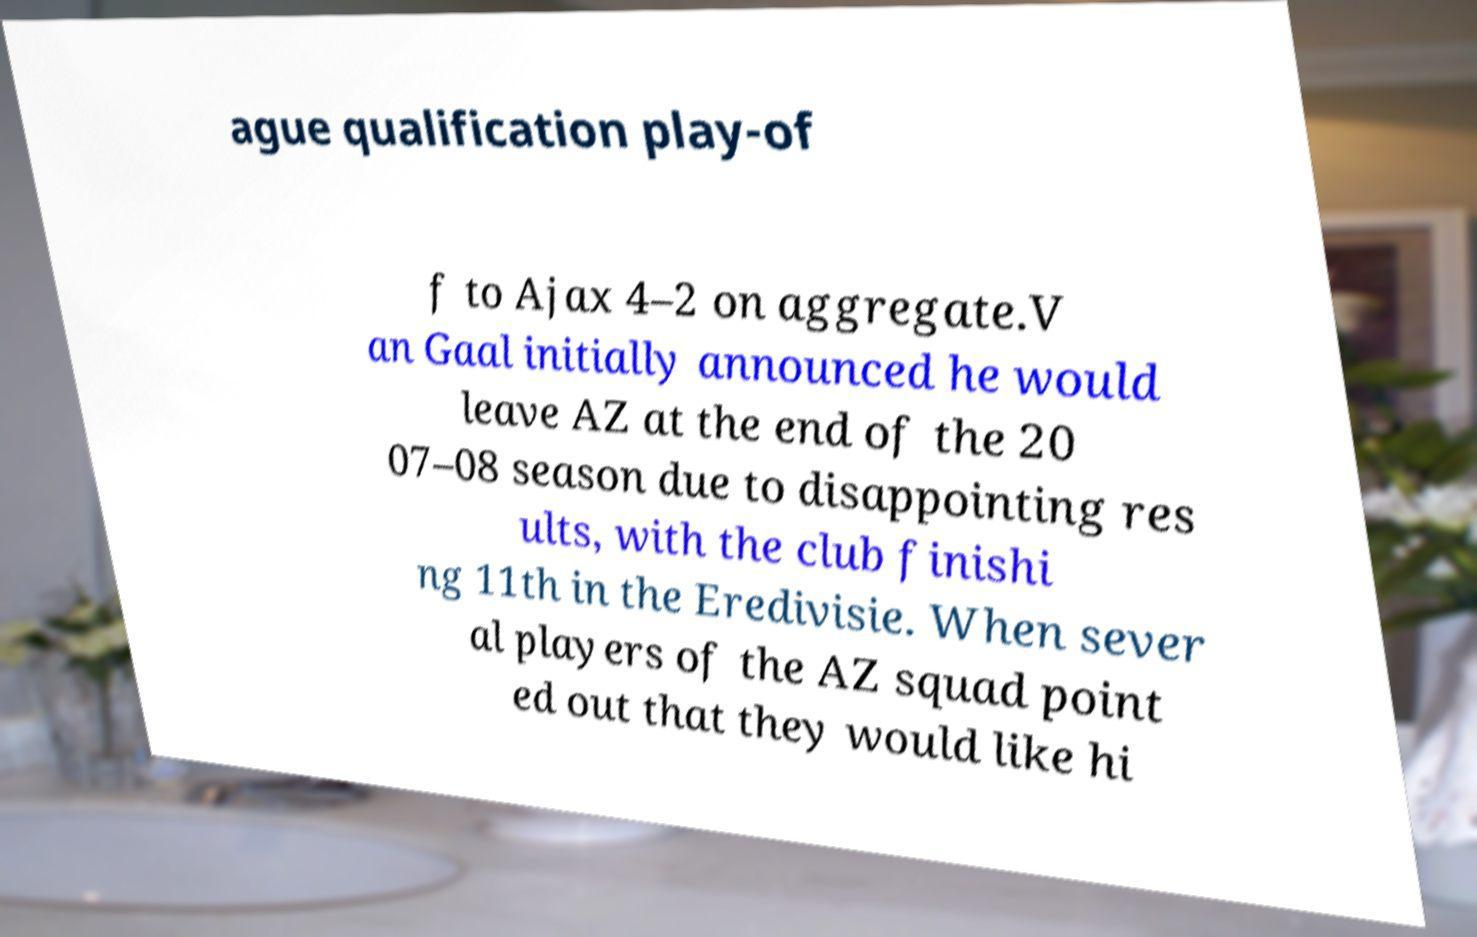Can you read and provide the text displayed in the image?This photo seems to have some interesting text. Can you extract and type it out for me? ague qualification play-of f to Ajax 4–2 on aggregate.V an Gaal initially announced he would leave AZ at the end of the 20 07–08 season due to disappointing res ults, with the club finishi ng 11th in the Eredivisie. When sever al players of the AZ squad point ed out that they would like hi 